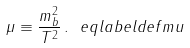<formula> <loc_0><loc_0><loc_500><loc_500>\mu \equiv \frac { m _ { b } ^ { 2 } } { T ^ { 2 } } \, . \ e q l a b e l { d e f m u }</formula> 